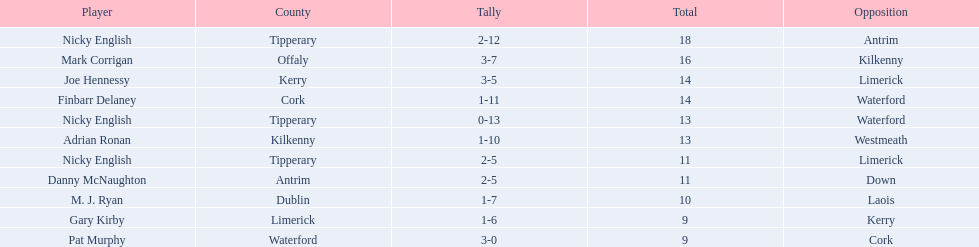What numbers are in the total column? 18, 16, 14, 14, 13, 13, 11, 11, 10, 9, 9. What row has the number 10 in the total column? 9, M. J. Ryan, Dublin, 1-7, 10, Laois. What name is in the player column for this row? M. J. Ryan. 